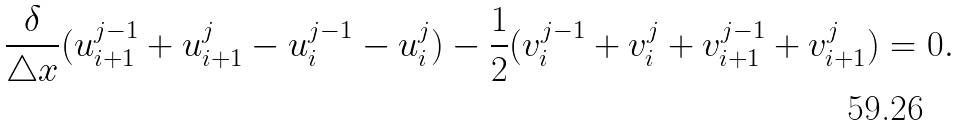Convert formula to latex. <formula><loc_0><loc_0><loc_500><loc_500>\frac { \delta } { \triangle x } ( u _ { i + 1 } ^ { j - 1 } + u _ { i + 1 } ^ { j } - u _ { i } ^ { j - 1 } - u _ { i } ^ { j } ) - \frac { 1 } { 2 } ( v _ { i } ^ { j - 1 } + v _ { i } ^ { j } + v _ { i + 1 } ^ { j - 1 } + v _ { i + 1 } ^ { j } ) = 0 .</formula> 